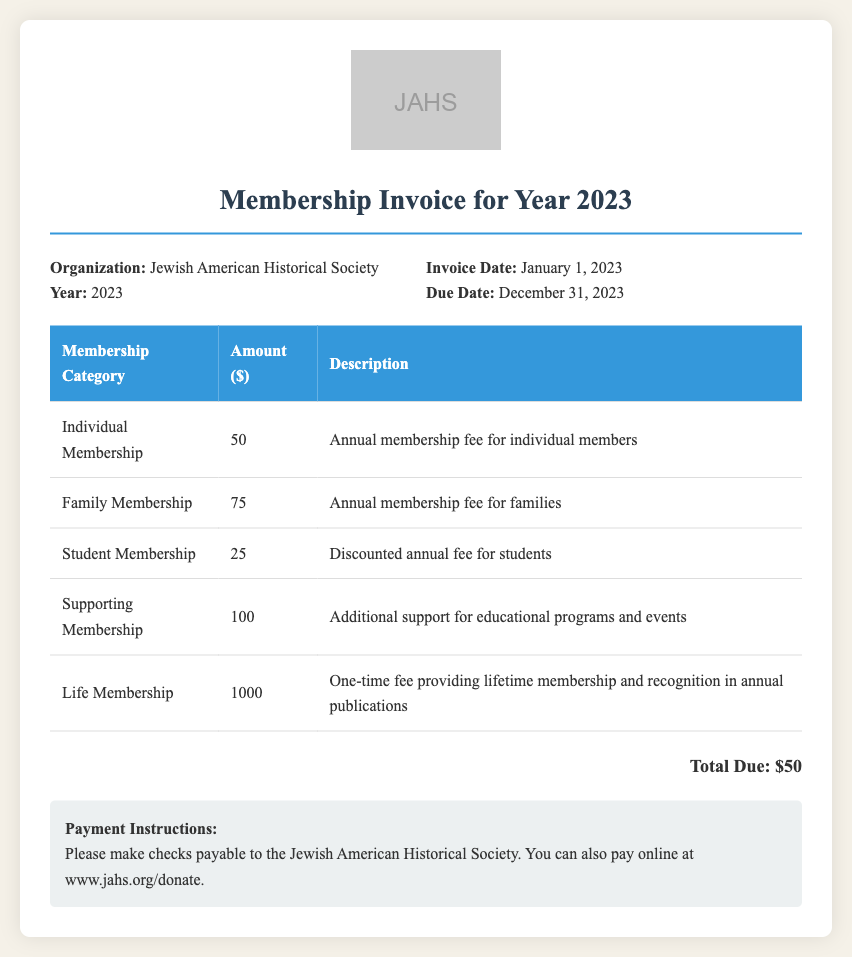What is the organization name? The organization name is listed at the top of the document.
Answer: Jewish American Historical Society What is the total due amount for 2023? The total due amount is stated in the document after the table.
Answer: $50 What is the due date for the membership invoice? The due date is specified in the invoice details section of the document.
Answer: December 31, 2023 How much is the fee for a Family Membership? The fee is provided in the table under the Membership Category section.
Answer: 75 What is the description for Life Membership? The description is included in the table next to the Life Membership category.
Answer: One-time fee providing lifetime membership and recognition in annual publications What type of membership has a discounted fee? The type of membership with a discounted fee can be found in the membership categories.
Answer: Student Membership How can payments be made according to the instructions? The payment methods are detailed in the payment instructions section of the document.
Answer: Checks or online What is the invoice date for this membership invoice? The invoice date is found in the invoice details section.
Answer: January 1, 2023 What is the fee for Supporting Membership? The fee for Supporting Membership is stated in the table of membership categories.
Answer: 100 